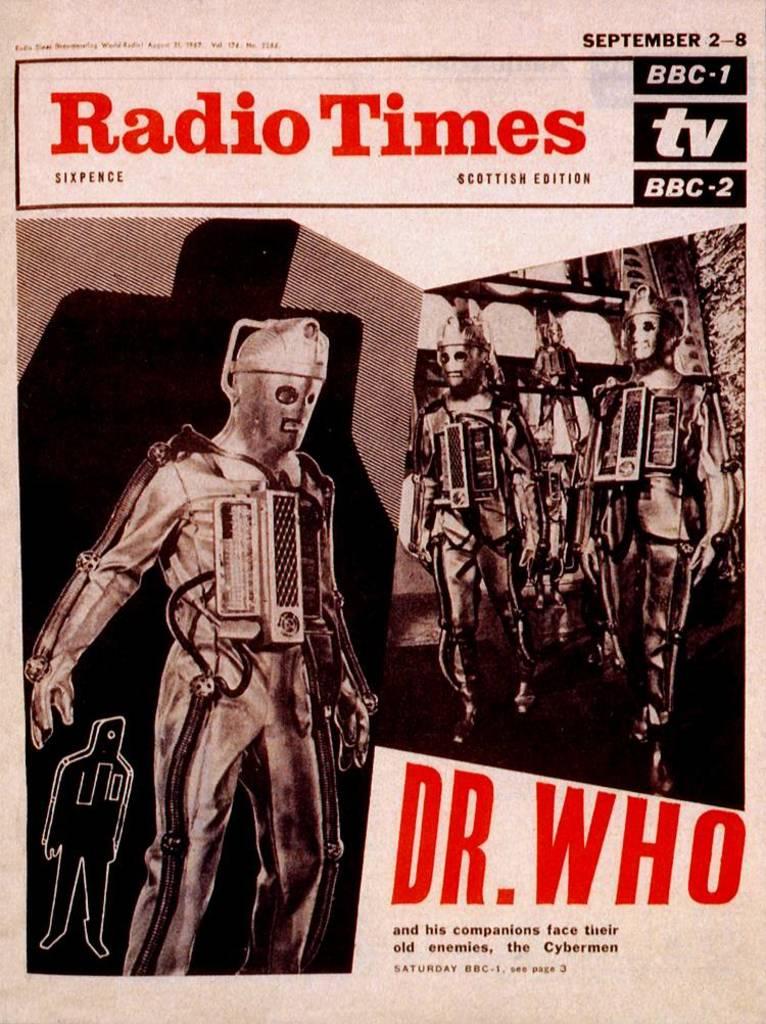Is this a doctor advert?
Make the answer very short. No. What is the date on the magazine?
Provide a short and direct response. September 2-8. 